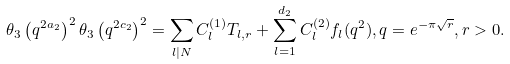<formula> <loc_0><loc_0><loc_500><loc_500>\theta _ { 3 } \left ( q ^ { 2 a _ { 2 } } \right ) ^ { 2 } \theta _ { 3 } \left ( q ^ { 2 c _ { 2 } } \right ) ^ { 2 } = \sum _ { l | N } C ^ { ( 1 ) } _ { l } T _ { l , r } + \sum ^ { d _ { 2 } } _ { l = 1 } C ^ { ( 2 ) } _ { l } f _ { l } ( q ^ { 2 } ) , q = e ^ { - \pi \sqrt { r } } , r > 0 .</formula> 